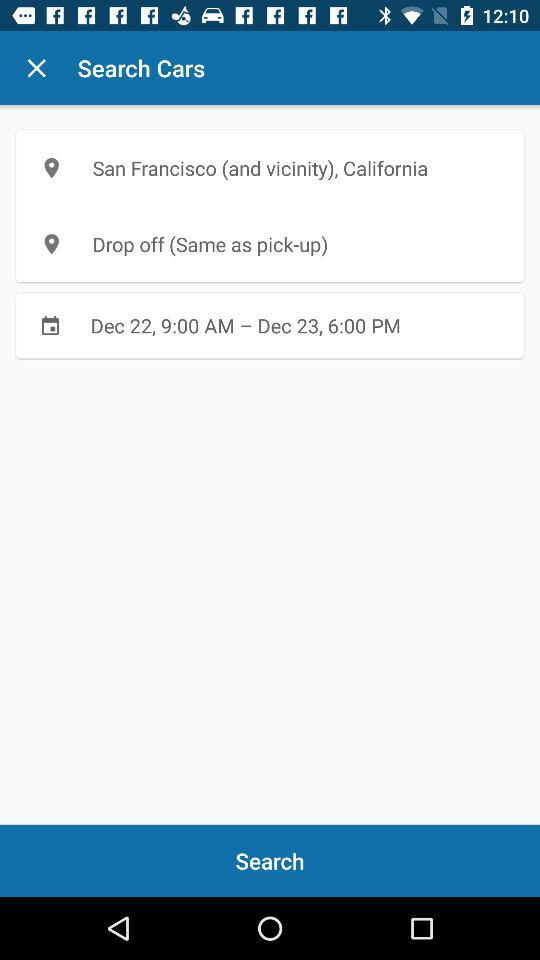What is the location? The location is San Francisco (and vicinity), California. 